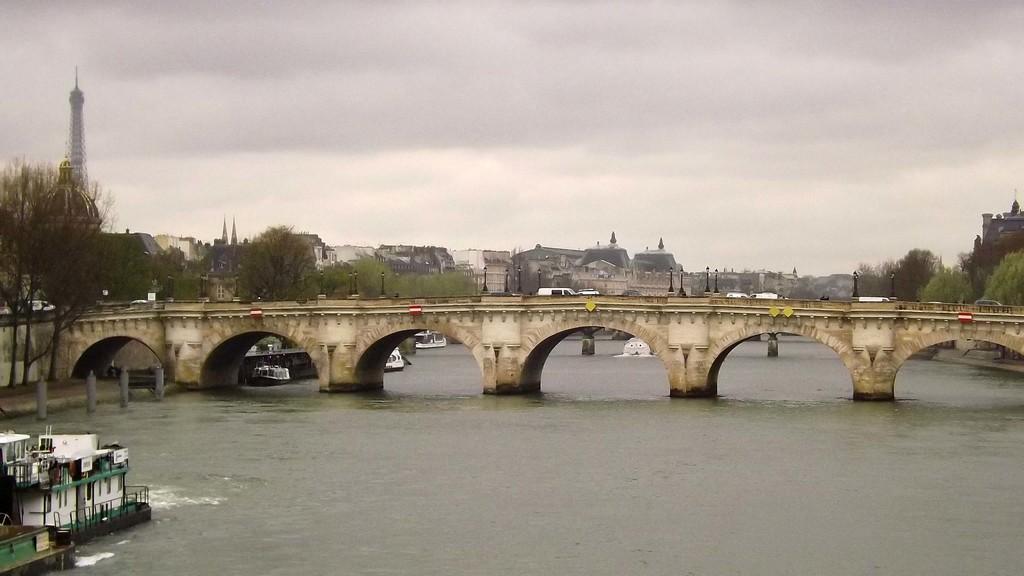How would you summarize this image in a sentence or two? In this picture we can see a river under a long tunnel bridge. In the background, we can see many houses and trees. The sky is gloomy. 